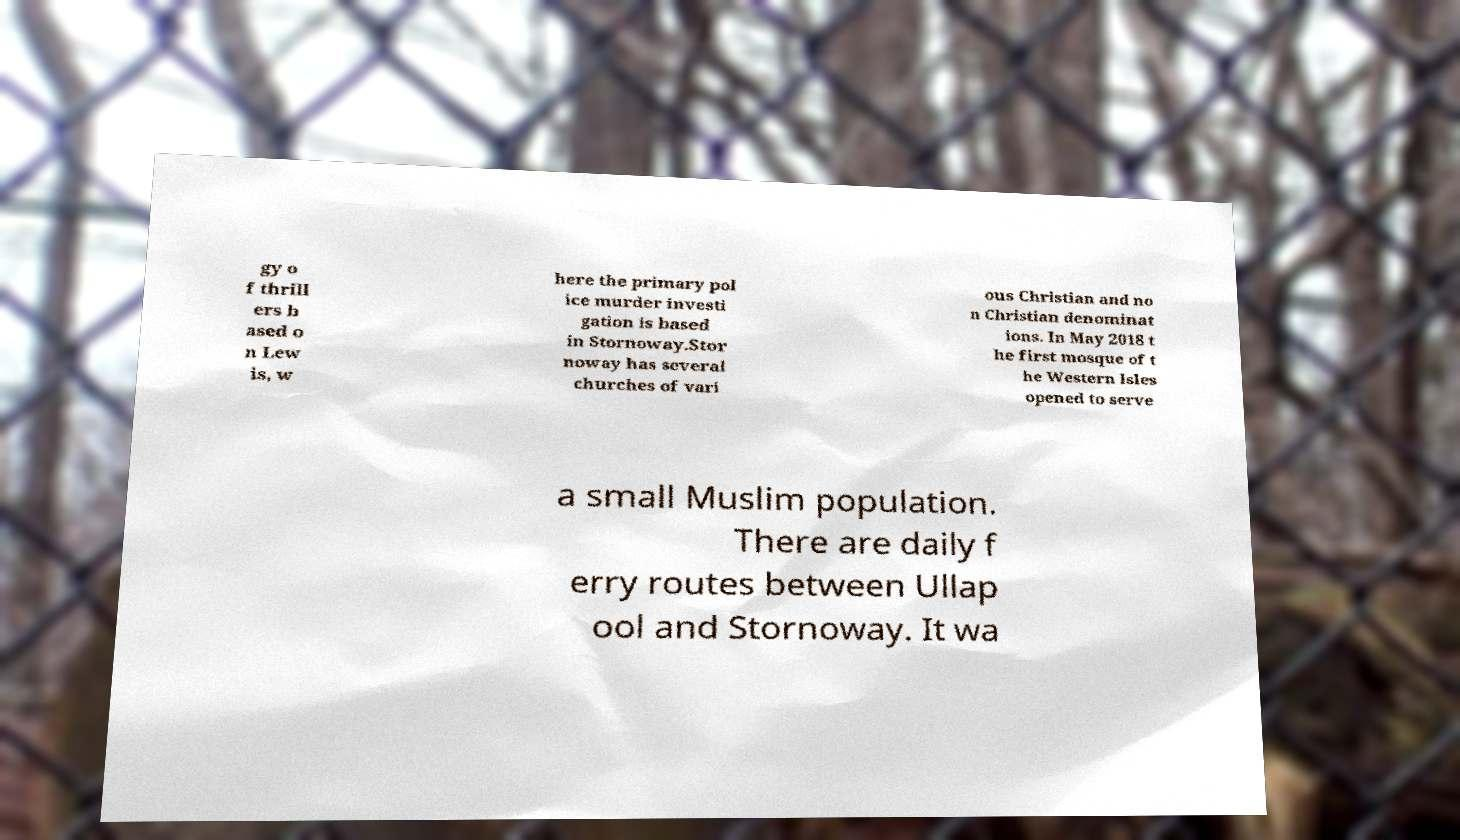There's text embedded in this image that I need extracted. Can you transcribe it verbatim? gy o f thrill ers b ased o n Lew is, w here the primary pol ice murder investi gation is based in Stornoway.Stor noway has several churches of vari ous Christian and no n Christian denominat ions. In May 2018 t he first mosque of t he Western Isles opened to serve a small Muslim population. There are daily f erry routes between Ullap ool and Stornoway. It wa 